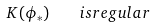<formula> <loc_0><loc_0><loc_500><loc_500>K ( \phi _ { * } ) \quad i s r e g u l a r</formula> 